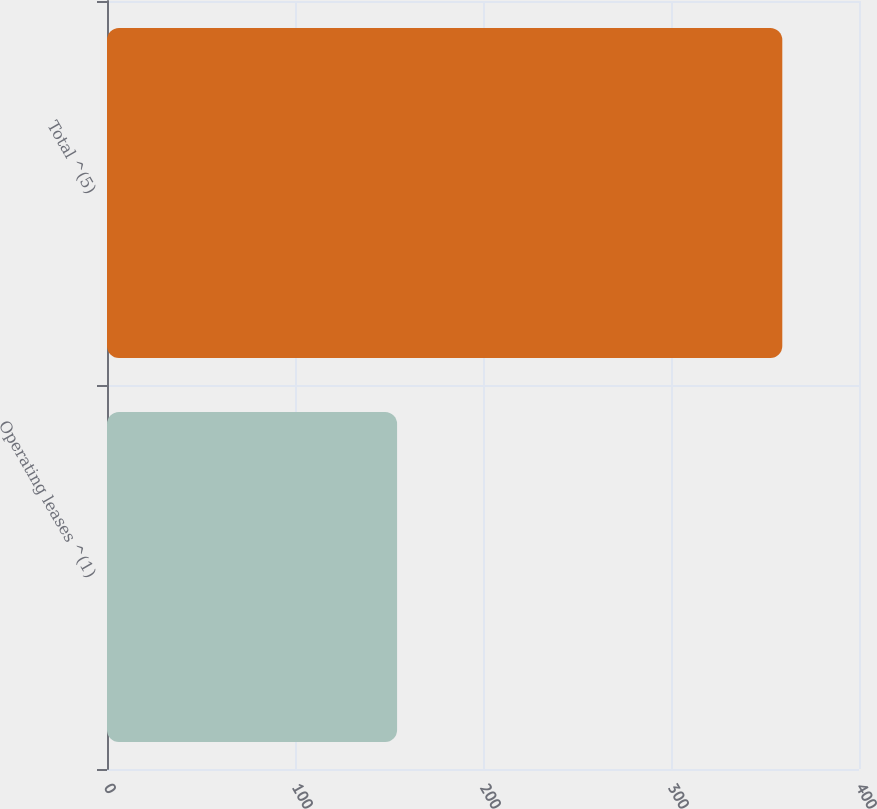Convert chart to OTSL. <chart><loc_0><loc_0><loc_500><loc_500><bar_chart><fcel>Operating leases ^(1)<fcel>Total ^(5)<nl><fcel>154.3<fcel>359.2<nl></chart> 